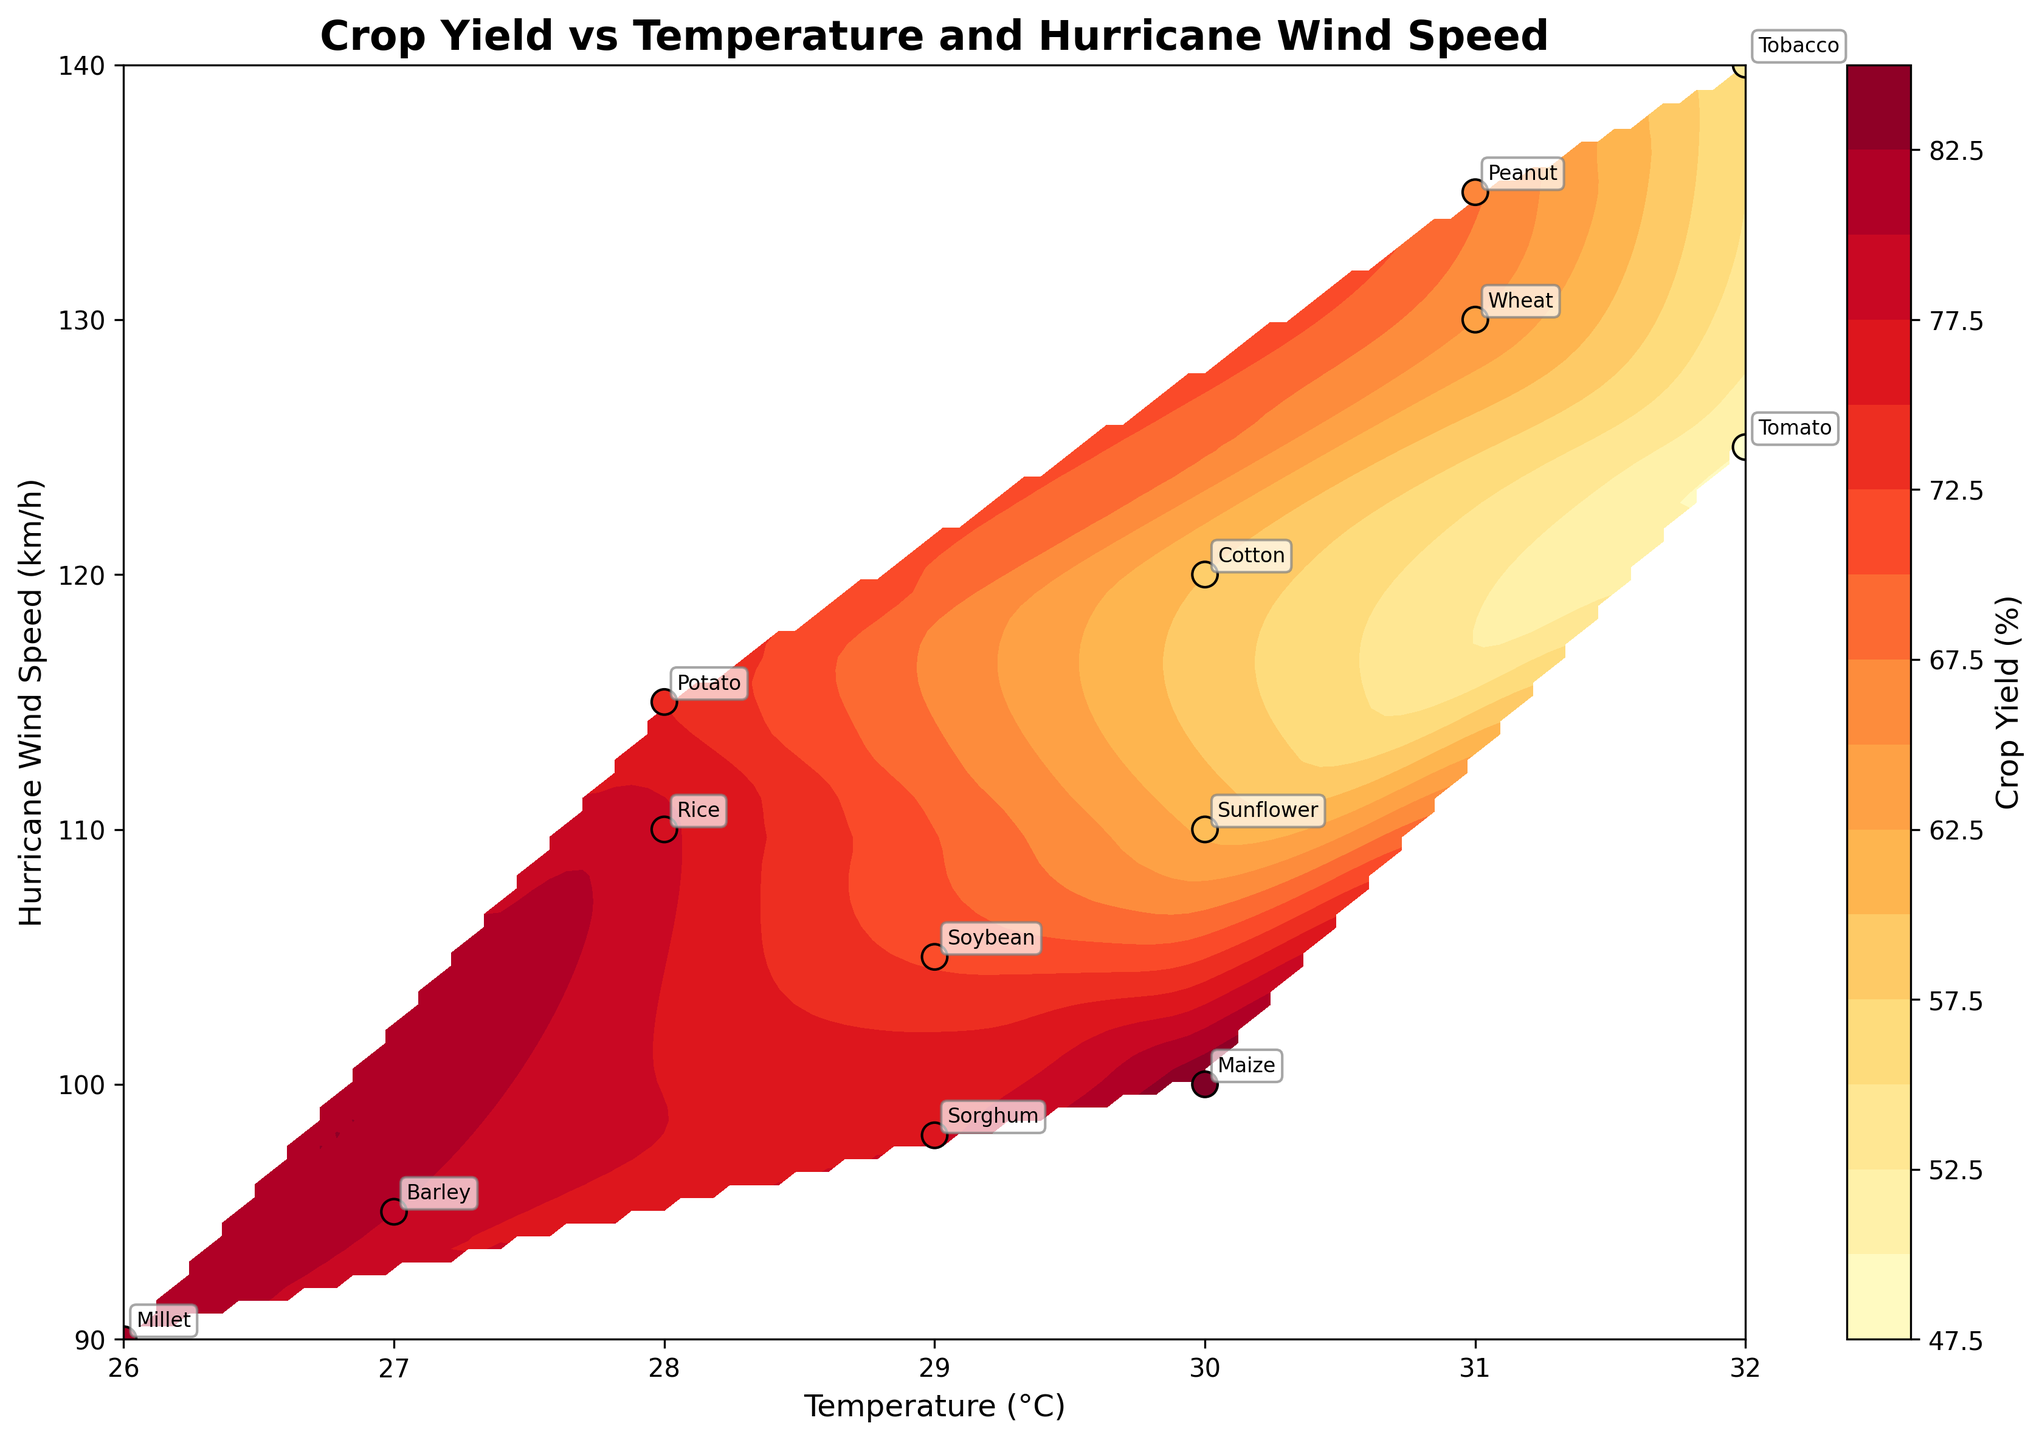How many different crop types are labeled on the figure? Count the unique crop labels annotated on the figure. There are labels for Maize, Rice, Wheat, Soybean, Tomato, Barley, Cotton, Potato, Peanut, Sorghum, Tobacco, Millet, and Sunflower, making for a total of 13 unique crop types.
Answer: 13 What is the temperature and wind speed for the crop with the highest yield? Look at the crop label with the highest yield percentage. Millet has the highest yield of 82%. The corresponding temperature is 26°C, and the wind speed is 90 km/h.
Answer: 26°C and 90 km/h Which crop type has the lowest yield, and what are its temperature and wind speed conditions? Identify the crop label with the lowest yield percentage. Tomato has the lowest yield of 50%. The corresponding temperature and wind speed are 32°C and 125 km/h, respectively.
Answer: Tomato, 32°C and 125 km/h Between which temperature and wind speed ranges do the highest yields generally cluster? Observe the contour plot and scatter points to determine where the highest yield percentages (typically shown in lighter colors) are concentrated. The highest yields cluster in the temperature range of 26-30°C and wind speeds of 90-105 km/h.
Answer: 26-30°C and 90-105 km/h Which crop types have a yield percentage between 60% and 70%, and what are their respective temperatures and wind speeds? Identify the scatter points and labels that fall within the 60-70% yield range. Cotton (60%), Sunflower (62%), and Peanut (68%) fall within this range. Their respective temperature and wind speed conditions are Cotton: 30°C, 120 km/h; Sunflower: 30°C, 110 km/h; Peanut: 31°C, 135 km/h.
Answer: Cotton (30°C, 120 km/h), Sunflower (30°C, 110 km/h), Peanut (31°C, 135 km/h) What is the general trend observed between temperature and crop yield? Look at the contour lines and the distribution of yields in relation to temperature. Generally, as the temperature increases, the crop yield tends to decrease, especially noticeable at temperatures above 30°C.
Answer: Yield decreases with higher temperatures Which hurricane wind speed corresponds to the lowest crop yield on the plot? Locate the scatter point with the lowest yield percentage on the figure. Tomato has the lowest yield at 50%, which happens at a hurricane wind speed of 125 km/h.
Answer: 125 km/h Are there any crop types that perform well under both low and high temperatures? Check for crop labels that appear under both low and high-temperature conditions with relatively high yields. Maize and Barley appear under different temperature conditions (30°C and 27°C) and maintain relatively high yields (85% and 80%, respectively).
Answer: Maize and Barley What can be inferred about the resilience of Barley compared to Millet in hurricane events? Compare the yield percentages and wind speeds for Barley and Millet. Barley has a yield of 80% at a wind speed of 95 km/h, while Millet has a higher yield of 82% at a lower wind speed of 90 km/h. This suggests that Barley is resilient but Millet yields slightly better under lower wind speeds.
Answer: Millet yields slightly better under lower wind speeds 